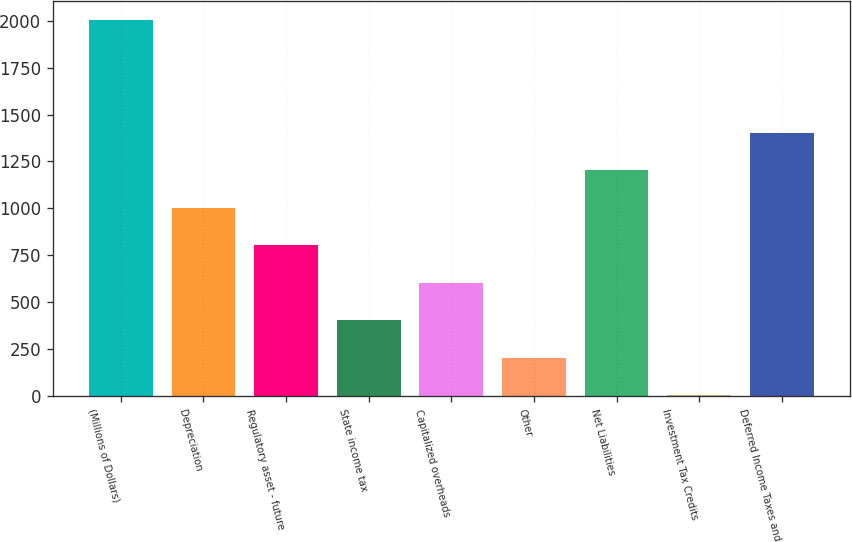Convert chart. <chart><loc_0><loc_0><loc_500><loc_500><bar_chart><fcel>(Millions of Dollars)<fcel>Depreciation<fcel>Regulatory asset - future<fcel>State income tax<fcel>Capitalized overheads<fcel>Other<fcel>Net Liabilities<fcel>Investment Tax Credits<fcel>Deferred Income Taxes and<nl><fcel>2003<fcel>1004<fcel>804.2<fcel>404.6<fcel>604.4<fcel>204.8<fcel>1203.8<fcel>5<fcel>1403.6<nl></chart> 